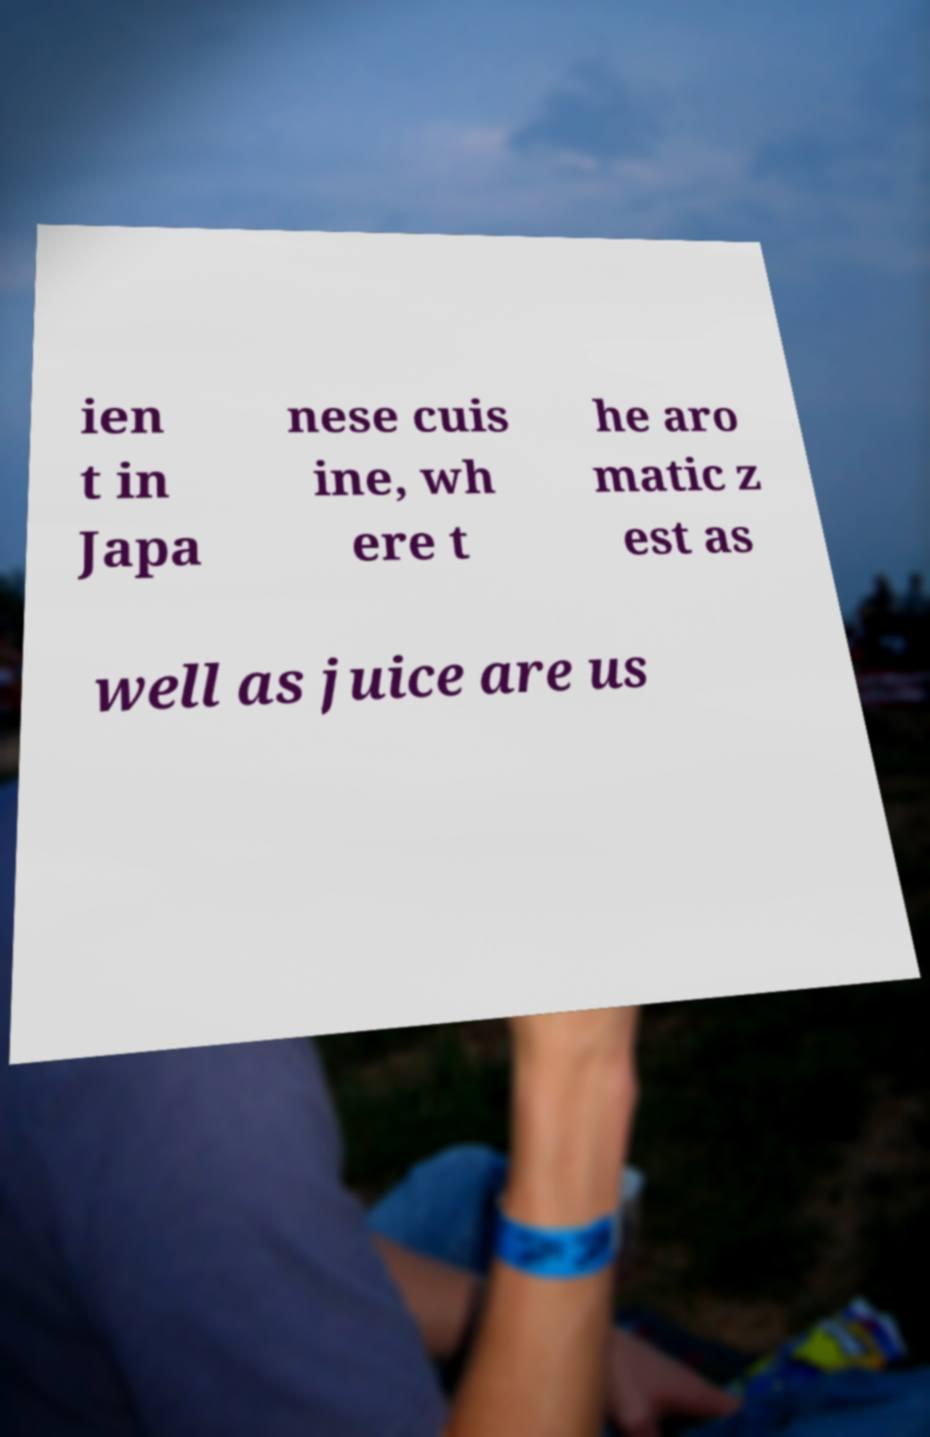There's text embedded in this image that I need extracted. Can you transcribe it verbatim? ien t in Japa nese cuis ine, wh ere t he aro matic z est as well as juice are us 